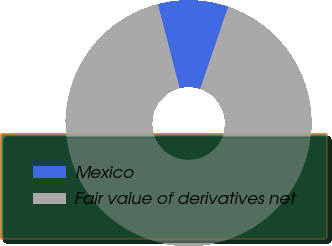<chart> <loc_0><loc_0><loc_500><loc_500><pie_chart><fcel>Mexico<fcel>Fair value of derivatives net<nl><fcel>9.24%<fcel>90.76%<nl></chart> 